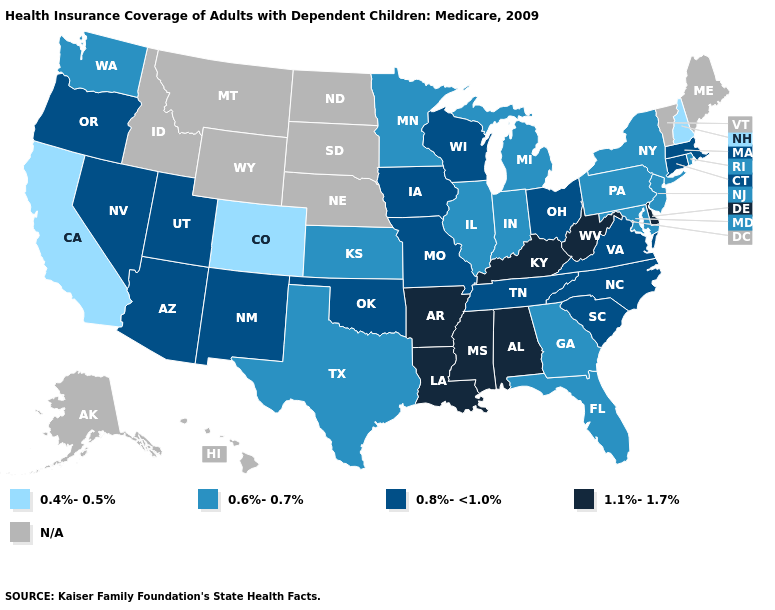Is the legend a continuous bar?
Write a very short answer. No. Name the states that have a value in the range 0.8%-<1.0%?
Keep it brief. Arizona, Connecticut, Iowa, Massachusetts, Missouri, Nevada, New Mexico, North Carolina, Ohio, Oklahoma, Oregon, South Carolina, Tennessee, Utah, Virginia, Wisconsin. Which states have the lowest value in the South?
Answer briefly. Florida, Georgia, Maryland, Texas. Name the states that have a value in the range 0.4%-0.5%?
Answer briefly. California, Colorado, New Hampshire. Name the states that have a value in the range N/A?
Quick response, please. Alaska, Hawaii, Idaho, Maine, Montana, Nebraska, North Dakota, South Dakota, Vermont, Wyoming. Name the states that have a value in the range 1.1%-1.7%?
Write a very short answer. Alabama, Arkansas, Delaware, Kentucky, Louisiana, Mississippi, West Virginia. What is the value of Texas?
Short answer required. 0.6%-0.7%. What is the value of Connecticut?
Be succinct. 0.8%-<1.0%. What is the highest value in states that border Iowa?
Answer briefly. 0.8%-<1.0%. Name the states that have a value in the range N/A?
Write a very short answer. Alaska, Hawaii, Idaho, Maine, Montana, Nebraska, North Dakota, South Dakota, Vermont, Wyoming. How many symbols are there in the legend?
Answer briefly. 5. What is the value of Vermont?
Answer briefly. N/A. Name the states that have a value in the range 1.1%-1.7%?
Be succinct. Alabama, Arkansas, Delaware, Kentucky, Louisiana, Mississippi, West Virginia. 